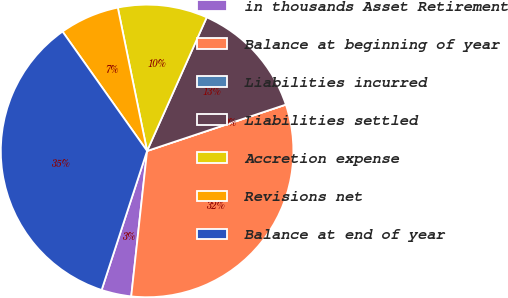Convert chart. <chart><loc_0><loc_0><loc_500><loc_500><pie_chart><fcel>in thousands Asset Retirement<fcel>Balance at beginning of year<fcel>Liabilities incurred<fcel>Liabilities settled<fcel>Accretion expense<fcel>Revisions net<fcel>Balance at end of year<nl><fcel>3.3%<fcel>31.86%<fcel>0.0%<fcel>13.19%<fcel>9.89%<fcel>6.6%<fcel>35.16%<nl></chart> 